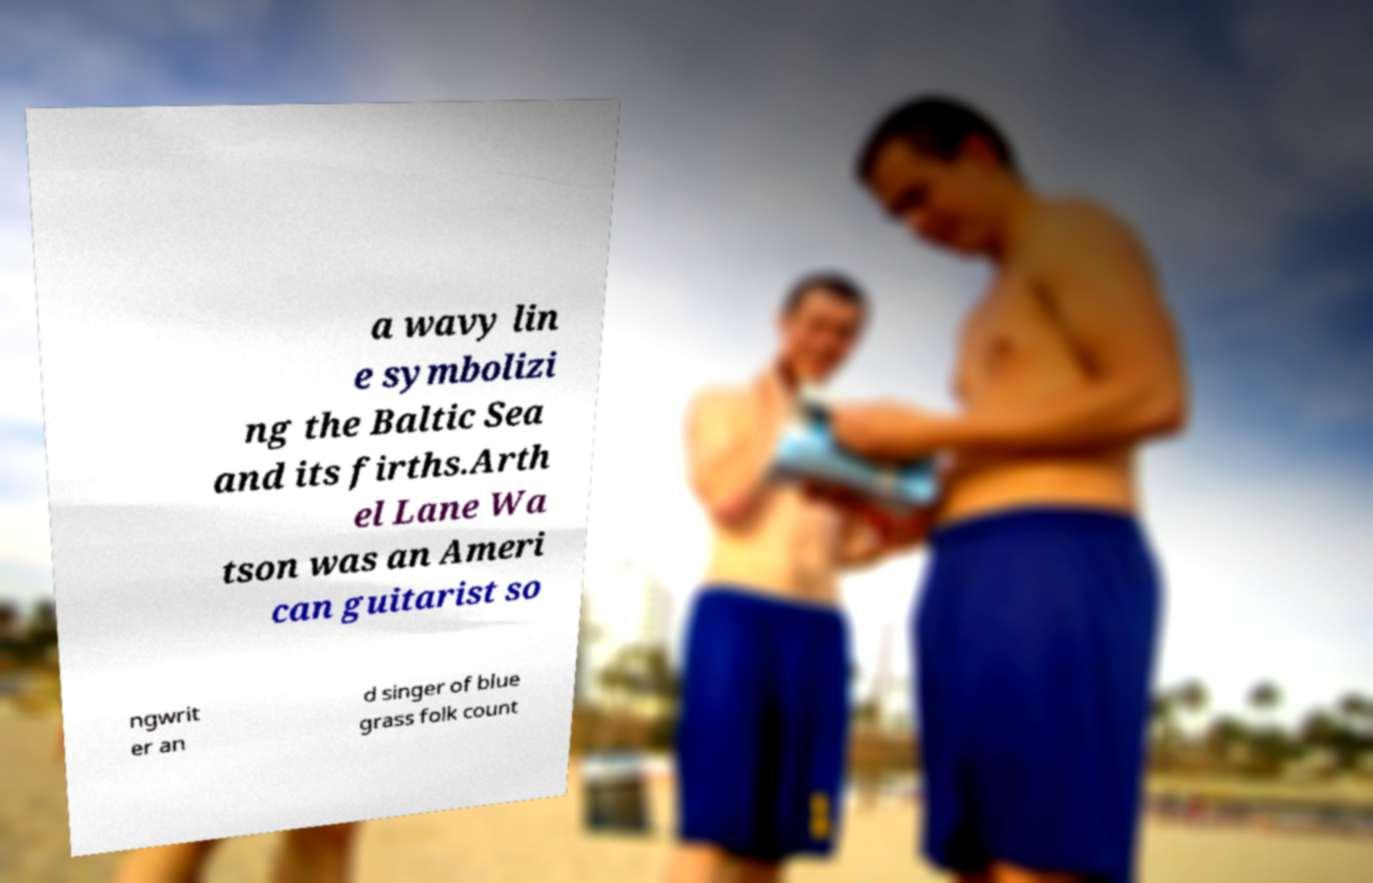I need the written content from this picture converted into text. Can you do that? a wavy lin e symbolizi ng the Baltic Sea and its firths.Arth el Lane Wa tson was an Ameri can guitarist so ngwrit er an d singer of blue grass folk count 